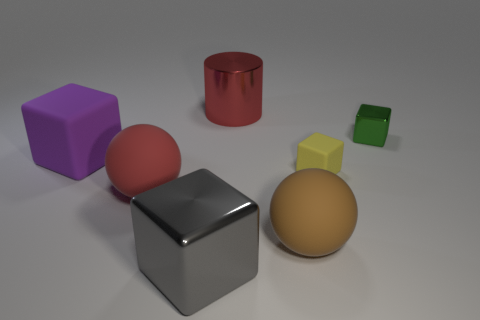What is the material of the large cube right of the big red sphere that is in front of the cylinder?
Make the answer very short. Metal. Are there the same number of yellow blocks that are to the right of the small shiny object and big gray objects?
Offer a terse response. No. There is a thing that is both to the left of the gray object and behind the large red rubber sphere; what size is it?
Offer a very short reply. Large. What is the color of the large matte ball to the left of the large red thing behind the green cube?
Your response must be concise. Red. What number of red objects are tiny blocks or metallic cubes?
Keep it short and to the point. 0. There is a object that is both behind the tiny yellow rubber object and in front of the green cube; what color is it?
Your answer should be very brief. Purple. What number of tiny things are blue cylinders or purple cubes?
Your response must be concise. 0. What size is the green thing that is the same shape as the small yellow thing?
Offer a terse response. Small. What is the shape of the small green thing?
Make the answer very short. Cube. Is the material of the large red sphere the same as the big cube that is in front of the brown matte thing?
Ensure brevity in your answer.  No. 